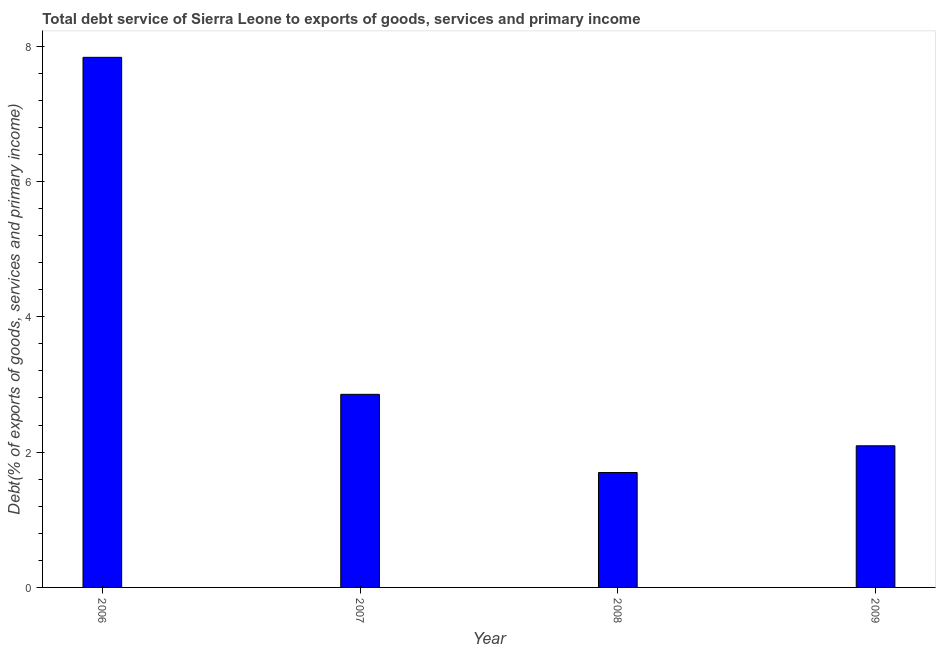What is the title of the graph?
Offer a terse response. Total debt service of Sierra Leone to exports of goods, services and primary income. What is the label or title of the X-axis?
Ensure brevity in your answer.  Year. What is the label or title of the Y-axis?
Offer a very short reply. Debt(% of exports of goods, services and primary income). What is the total debt service in 2008?
Make the answer very short. 1.7. Across all years, what is the maximum total debt service?
Your answer should be very brief. 7.84. Across all years, what is the minimum total debt service?
Offer a terse response. 1.7. In which year was the total debt service maximum?
Make the answer very short. 2006. In which year was the total debt service minimum?
Your response must be concise. 2008. What is the sum of the total debt service?
Your answer should be very brief. 14.48. What is the difference between the total debt service in 2007 and 2008?
Keep it short and to the point. 1.16. What is the average total debt service per year?
Offer a terse response. 3.62. What is the median total debt service?
Provide a succinct answer. 2.47. What is the ratio of the total debt service in 2006 to that in 2009?
Your answer should be compact. 3.74. What is the difference between the highest and the second highest total debt service?
Ensure brevity in your answer.  4.98. What is the difference between the highest and the lowest total debt service?
Offer a very short reply. 6.14. In how many years, is the total debt service greater than the average total debt service taken over all years?
Offer a terse response. 1. How many bars are there?
Your answer should be very brief. 4. How many years are there in the graph?
Give a very brief answer. 4. Are the values on the major ticks of Y-axis written in scientific E-notation?
Give a very brief answer. No. What is the Debt(% of exports of goods, services and primary income) in 2006?
Your answer should be compact. 7.84. What is the Debt(% of exports of goods, services and primary income) of 2007?
Give a very brief answer. 2.85. What is the Debt(% of exports of goods, services and primary income) of 2008?
Give a very brief answer. 1.7. What is the Debt(% of exports of goods, services and primary income) in 2009?
Make the answer very short. 2.09. What is the difference between the Debt(% of exports of goods, services and primary income) in 2006 and 2007?
Make the answer very short. 4.98. What is the difference between the Debt(% of exports of goods, services and primary income) in 2006 and 2008?
Offer a very short reply. 6.14. What is the difference between the Debt(% of exports of goods, services and primary income) in 2006 and 2009?
Keep it short and to the point. 5.74. What is the difference between the Debt(% of exports of goods, services and primary income) in 2007 and 2008?
Ensure brevity in your answer.  1.16. What is the difference between the Debt(% of exports of goods, services and primary income) in 2007 and 2009?
Your answer should be compact. 0.76. What is the difference between the Debt(% of exports of goods, services and primary income) in 2008 and 2009?
Provide a short and direct response. -0.4. What is the ratio of the Debt(% of exports of goods, services and primary income) in 2006 to that in 2007?
Give a very brief answer. 2.75. What is the ratio of the Debt(% of exports of goods, services and primary income) in 2006 to that in 2008?
Ensure brevity in your answer.  4.61. What is the ratio of the Debt(% of exports of goods, services and primary income) in 2006 to that in 2009?
Offer a terse response. 3.74. What is the ratio of the Debt(% of exports of goods, services and primary income) in 2007 to that in 2008?
Keep it short and to the point. 1.68. What is the ratio of the Debt(% of exports of goods, services and primary income) in 2007 to that in 2009?
Give a very brief answer. 1.36. What is the ratio of the Debt(% of exports of goods, services and primary income) in 2008 to that in 2009?
Make the answer very short. 0.81. 